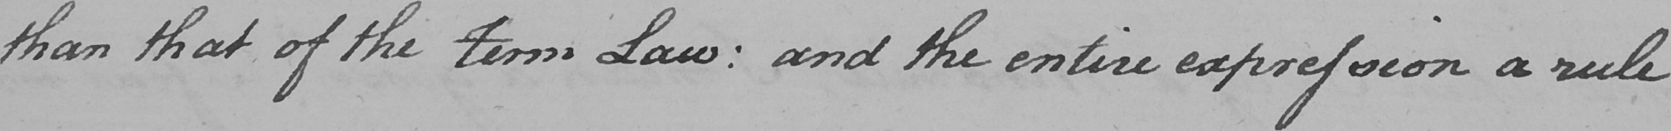Please transcribe the handwritten text in this image. than that of the term Law :  and the entire expression a rule 